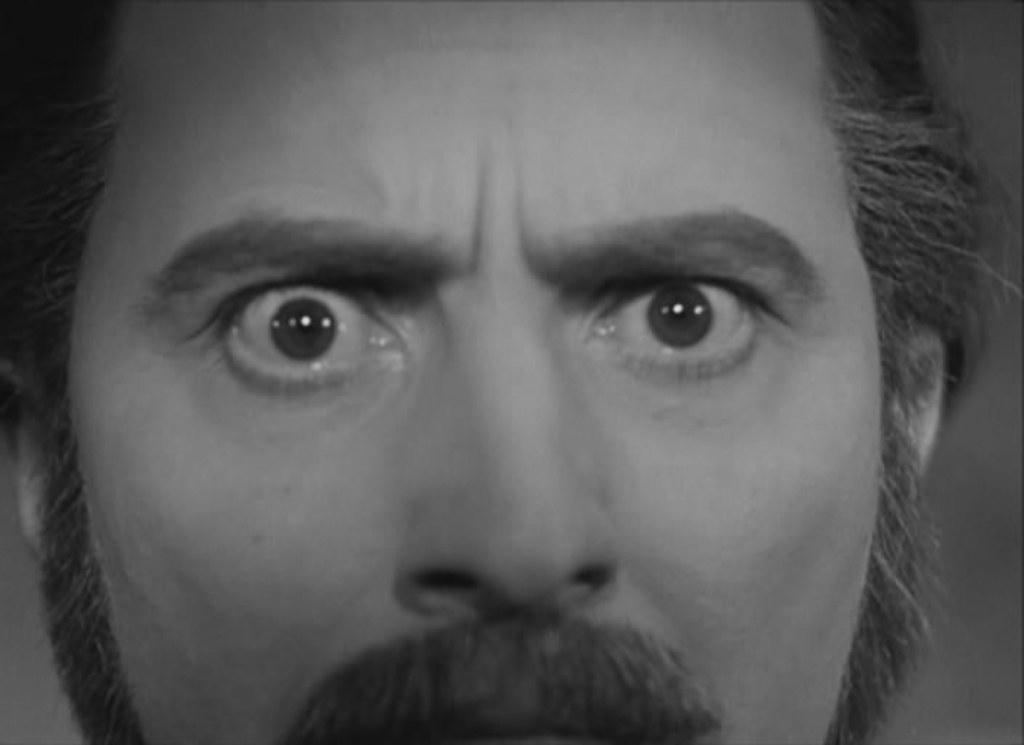How would you summarize this image in a sentence or two? This is the black and white picture of a man staring in the front. 